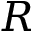Convert formula to latex. <formula><loc_0><loc_0><loc_500><loc_500>R</formula> 